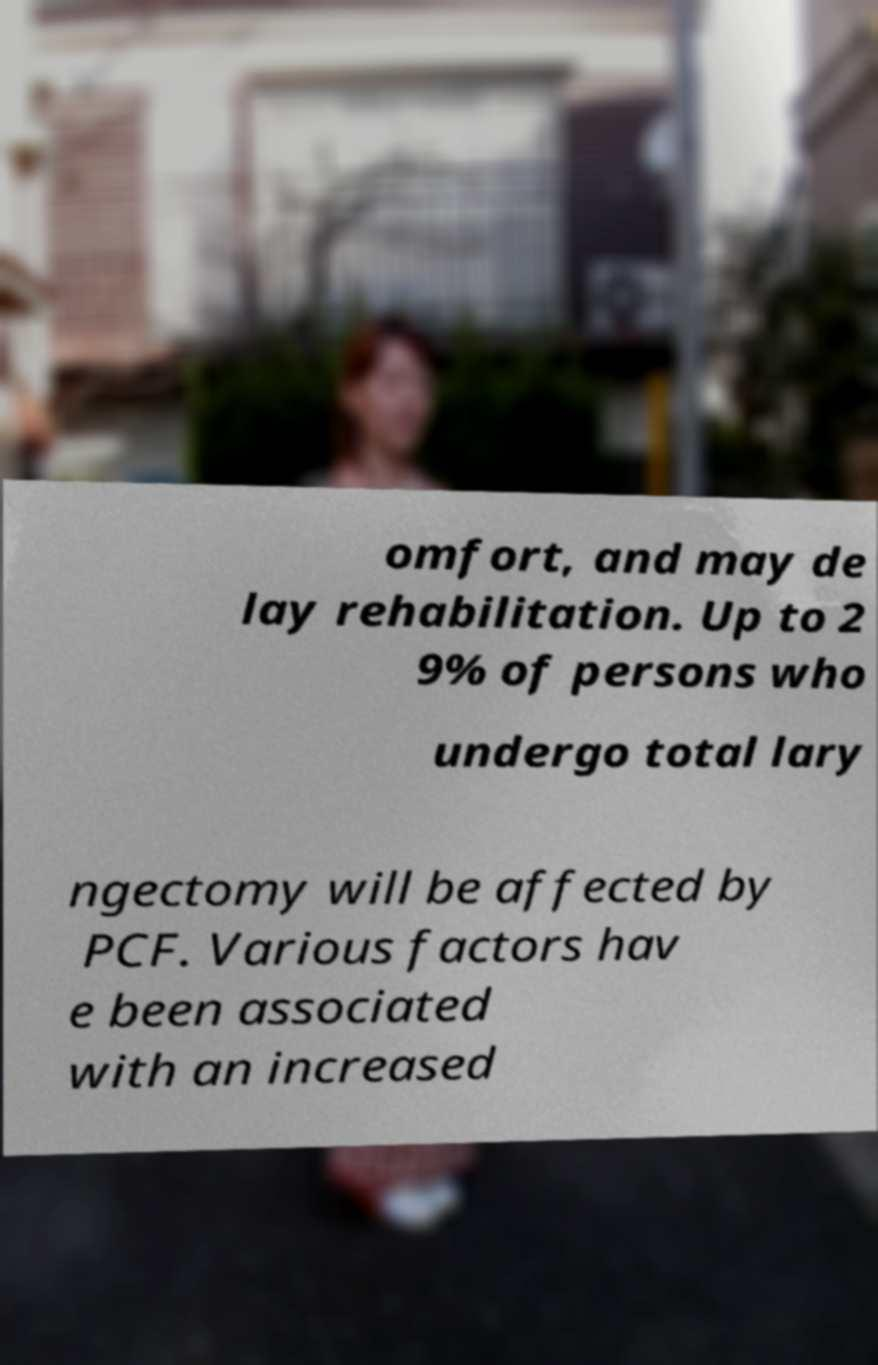Can you read and provide the text displayed in the image?This photo seems to have some interesting text. Can you extract and type it out for me? omfort, and may de lay rehabilitation. Up to 2 9% of persons who undergo total lary ngectomy will be affected by PCF. Various factors hav e been associated with an increased 